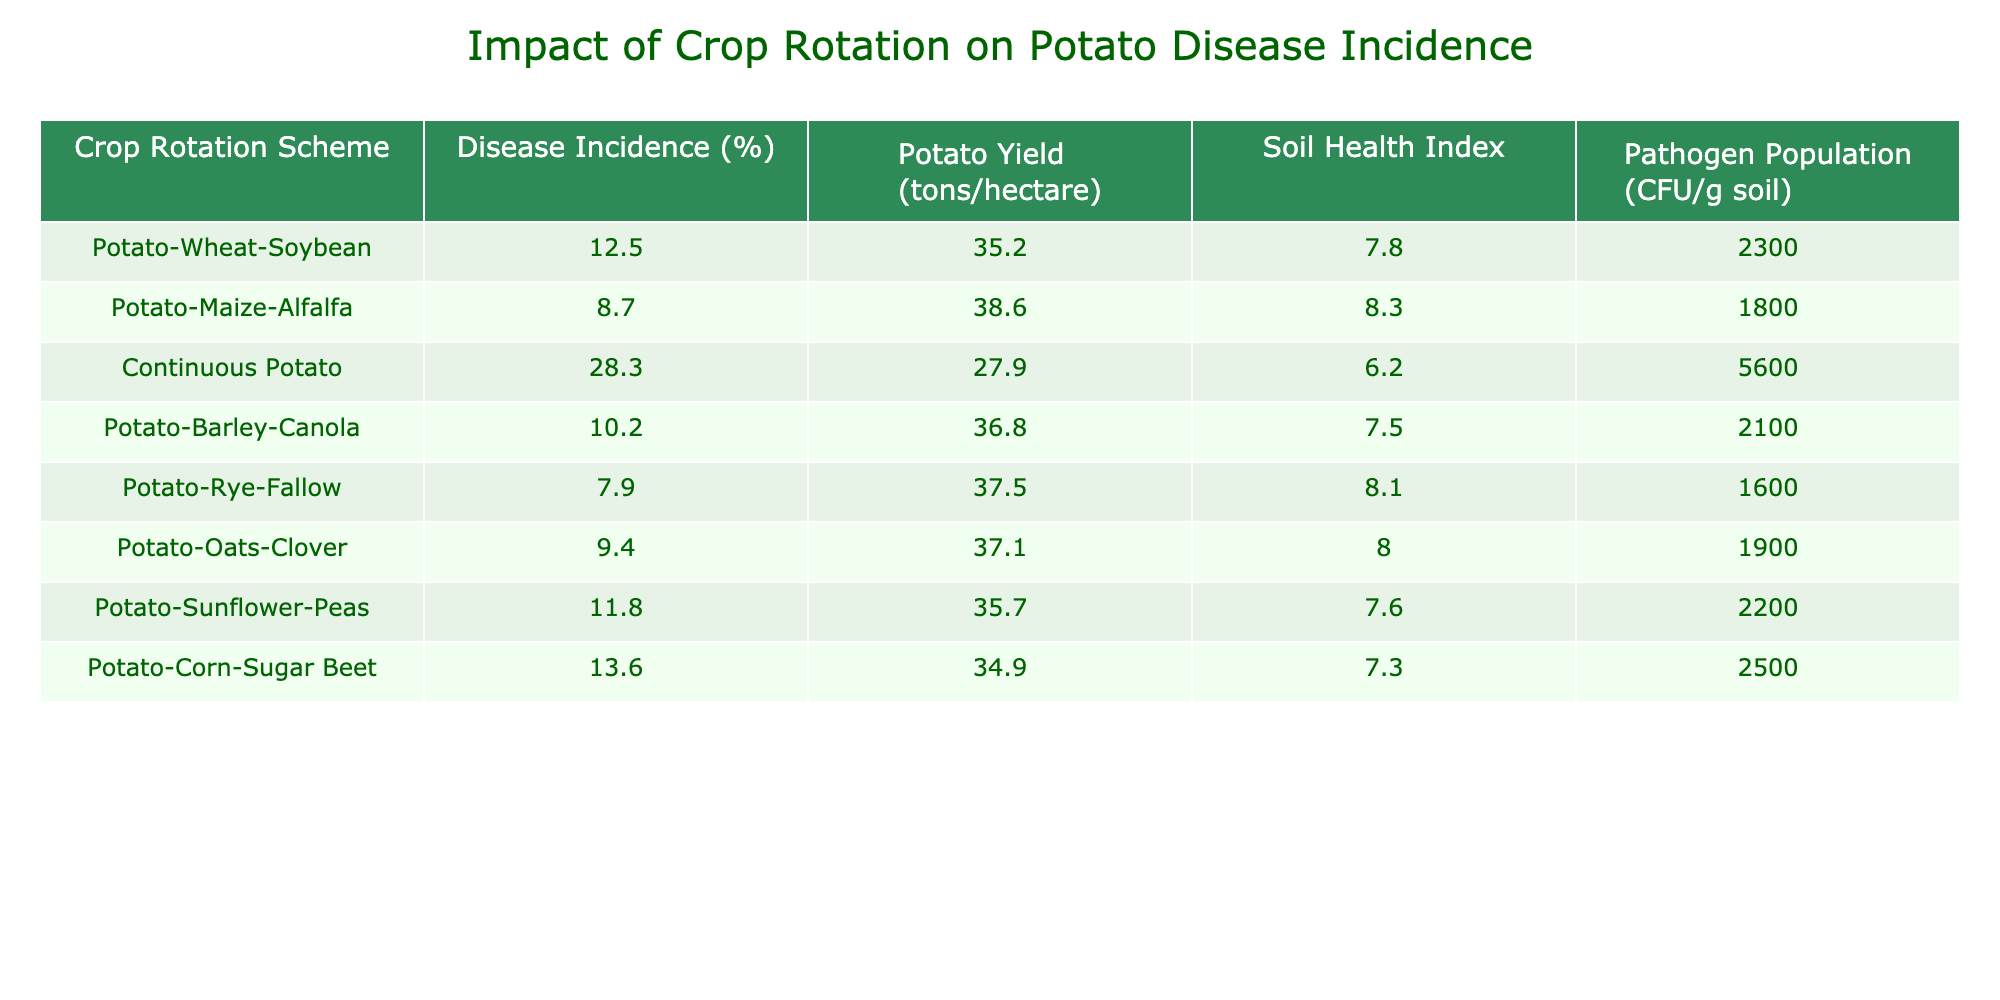What is the disease incidence percentage for the continuous potato rotation scheme? The table indicates that the disease incidence for the continuous potato rotation is listed under the "Disease Incidence (%)" column. It shows a value of 28.3% for this specific scheme.
Answer: 28.3% Which crop rotation scheme has the lowest disease incidence percentage? By examining the "Disease Incidence (%)" column, the scheme with the lowest recorded percentage is Potato-Rye-Fallow at 7.9%.
Answer: 7.9% What is the average potato yield across all crop rotation schemes? To find the average potato yield, we sum all the values in the "Potato Yield (tons/hectare)" column: (35.2 + 38.6 + 27.9 + 36.8 + 37.5 + 37.1 + 35.7 + 34.9) = 308.7 tons/hectare. Since there are 8 schemes, we divide by 8 to get the average: 308.7 / 8 = 38.59 tons/hectare.
Answer: 38.59 tons/hectare Is the pathogen population higher in any rotation scheme compared to continuous potato? We can see that the continuous potato scheme has a pathogen population of 5600 CFU/g of soil. Checking each scheme shows that none have a higher population; the maximum pathogen population in any other scheme is 2300 CFU/g in Potato-Wheat-Soybean. Therefore, the answer is no.
Answer: No Which crop rotation scheme has the best combination of disease incidence and potato yield? To assess the best combination, we can evaluate both the disease incidence and potato yield. The scheme with the lowest disease incidence is Potato-Rye-Fallow at 7.9% with a yield of 37.5 tons/hectare. The scheme with the highest yield, Potato-Maize-Alfalfa at 38.6 tons/hectare, has a disease incidence of 8.7%. Comparing these combinations, Potato-Maize-Alfalfa balances higher yield with low disease incidence relatively well, making it the best option.
Answer: Potato-Maize-Alfalfa What is the difference in soil health index between the best and worst rotation schemes? The best rotation scheme based on soil health index is Potato-Maize-Alfalfa, which has an index of 8.3, while the worst is Continuous Potato at 6.2. The difference is calculated as: 8.3 - 6.2 = 2.1.
Answer: 2.1 Are there any crop rotation schemes where the yield is below 30 tons/hectare? The table lists Continuous Potato with a yield of 27.9 tons/hectare, which is below 30 tons/hectare. Checking all other schemes confirms they all exceed this yield. Thus, there is one scheme that meets this criterion.
Answer: Yes 